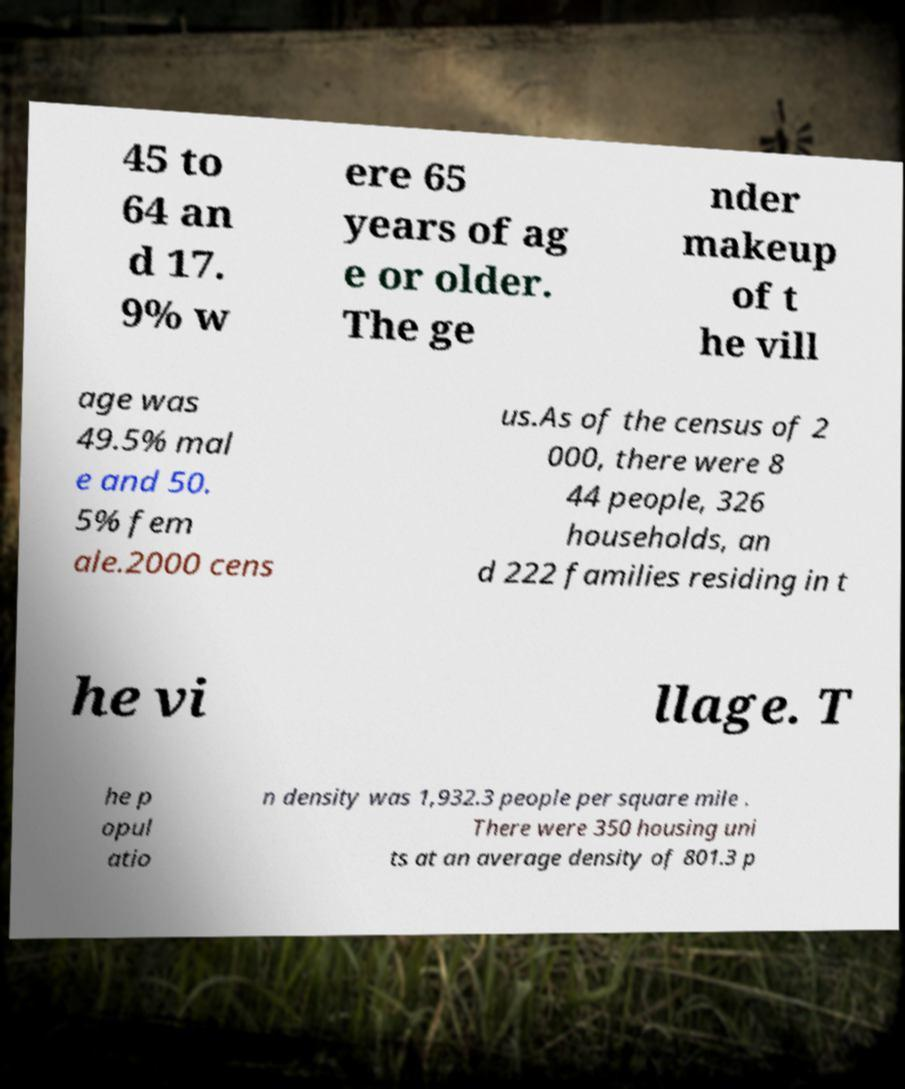What messages or text are displayed in this image? I need them in a readable, typed format. 45 to 64 an d 17. 9% w ere 65 years of ag e or older. The ge nder makeup of t he vill age was 49.5% mal e and 50. 5% fem ale.2000 cens us.As of the census of 2 000, there were 8 44 people, 326 households, an d 222 families residing in t he vi llage. T he p opul atio n density was 1,932.3 people per square mile . There were 350 housing uni ts at an average density of 801.3 p 